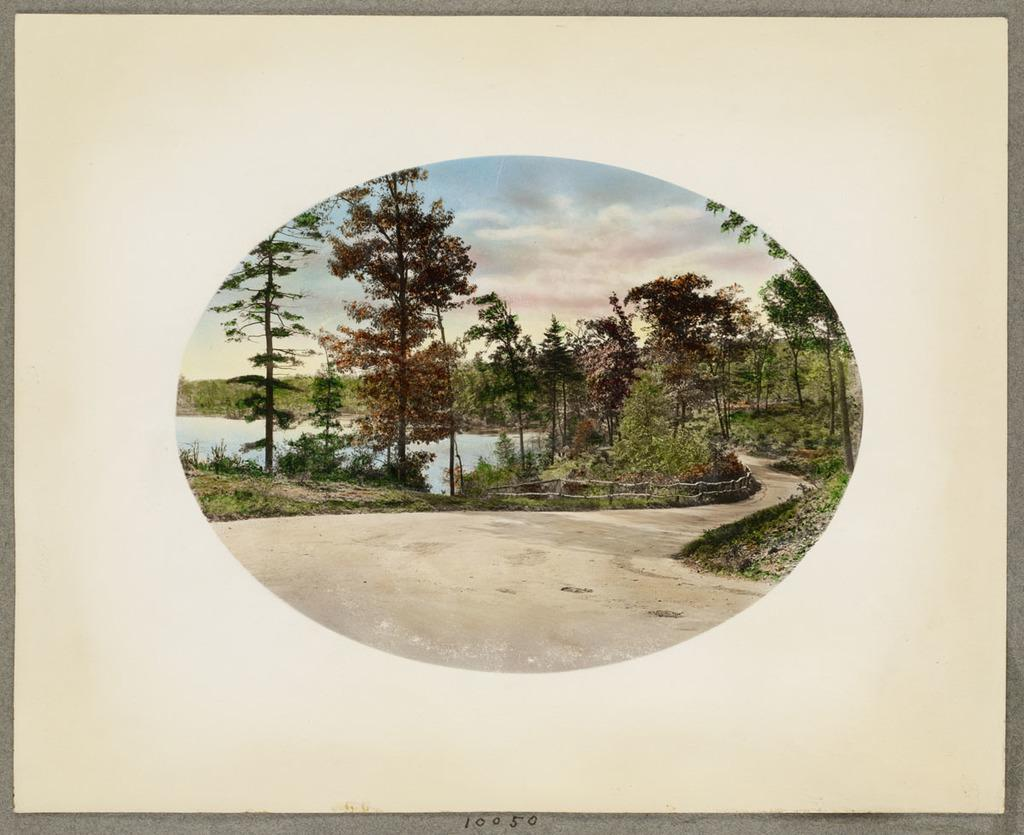What is on the paper that is visible in the image? There is a photo on the paper in the image. What can be seen in the photo? The photo contains trees, plants, a pathway, water, and the sky. What is the purpose of the numbers at the bottom of the image? The purpose of the numbers is not clear from the image alone, but they might indicate a sequence or reference for the photo. What type of quince is being served by the maid in the image? There is no quince or maid present in the image; it only contains a photo with various elements. 